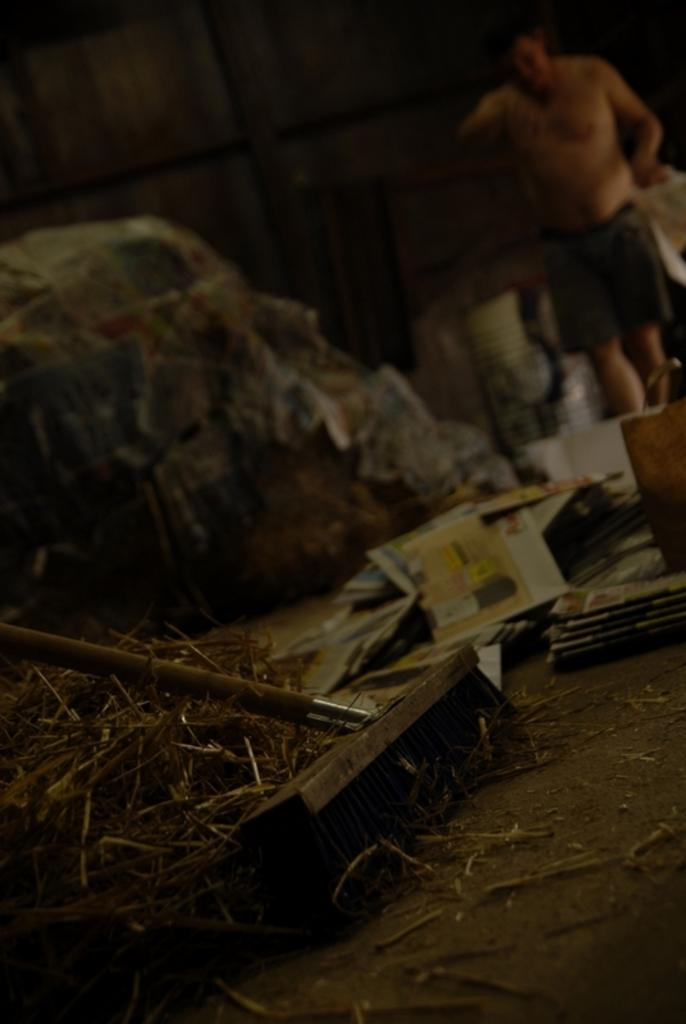What type of vegetation is present in the image? There is grass in the image. What tool is visible in the image? There is a cleaning brush in the image. What type of object is made of paper in the image? There is a paper in the image. What is covering something in the image? There is a cover in the image. What is on the floor in the image? There are objects on the floor in the image. How would you describe the background of the image? The background of the image is blurry. Can you identify any people in the image? Yes, there is a man visible in the background of the image. What type of yarn is the man swinging in the background of the image? There is no man swinging or yarn present in the image. What action is the grass performing in the image? Grass is not capable of performing actions; it is a stationary vegetation. 